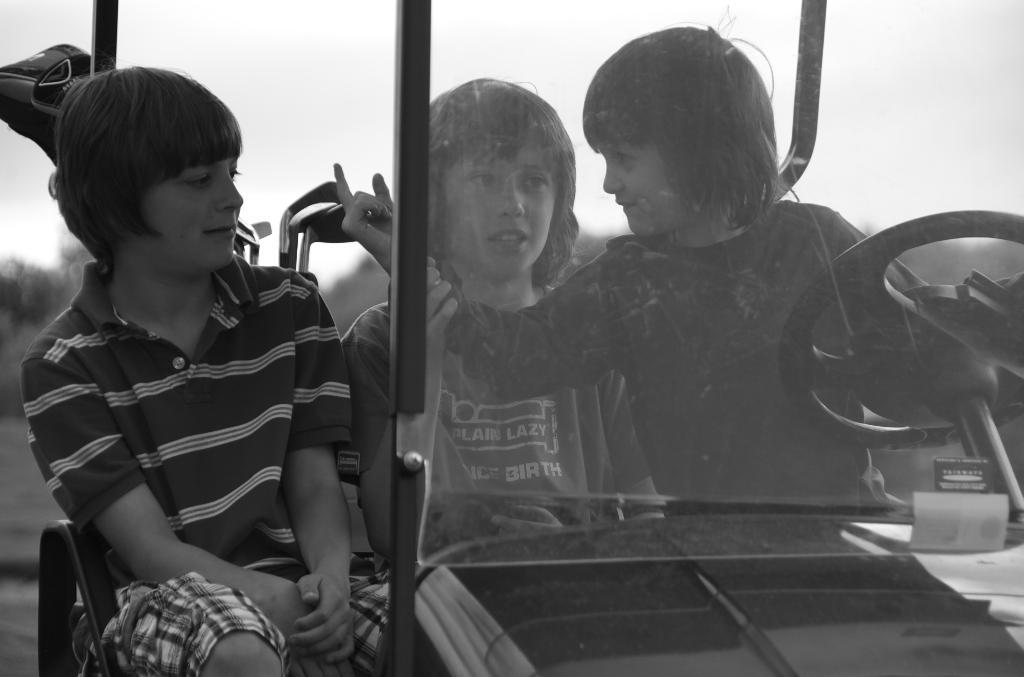What is the color scheme of the image? The image is black and white. What can be seen inside the vehicle in the image? There are kids sitting in a vehicle. What type of natural scenery is visible in the background of the image? There are trees in the background of the image. What part of the natural environment is visible in the background of the image? The sky is visible in the background of the image. What type of quilt is being used to cover the vehicle in the image? There is no quilt present in the image; it is a black and white image of kids sitting in a vehicle with trees and the sky visible in the background. 